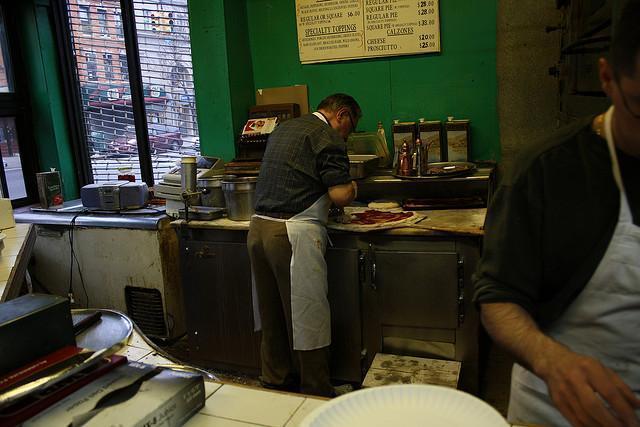How many people are in the picture?
Give a very brief answer. 2. How many ovens are there?
Give a very brief answer. 2. How many of the dogs have black spots?
Give a very brief answer. 0. 